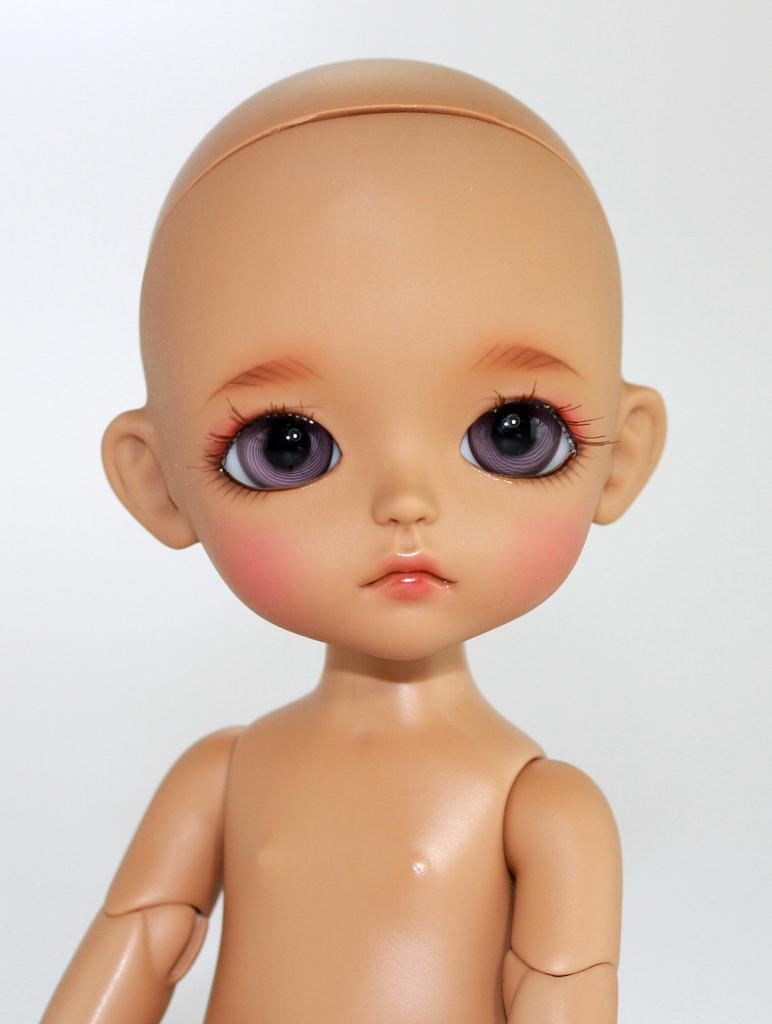What is present in the image? There is a doll in the image. Can you describe the color of the doll? The doll is brown in color. What is the color of the background in the image? The background of the image is white. What type of art can be seen on the elbow of the doll in the image? There is no art visible on the doll's elbow in the image, as the doll's elbow is not mentioned in the provided facts. How many cows are present in the image? There are no cows present in the image. 